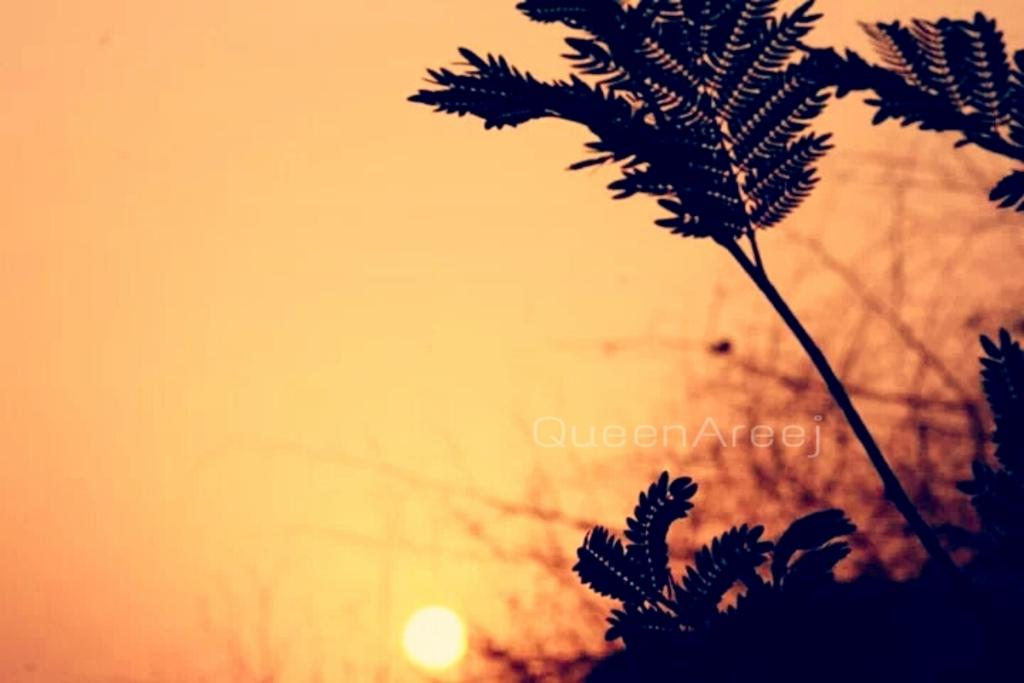What time of day is depicted in the image? The image is taken during sunset or sunrise. What can be seen in the foreground towards the right? There are trees in the foreground towards the right. What is the main celestial object in the background? The sun is in the center of the background. What color is the sky in the image? The sky is in a yellowish orange color. What type of carpenter is working on the camp in the image? There is no carpenter or camp present in the image; it features a sunset or sunrise with trees and the sun in the background. 